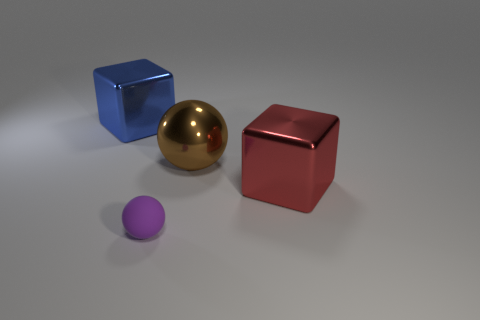Add 3 small gray blocks. How many objects exist? 7 Add 1 red metal things. How many red metal things are left? 2 Add 2 yellow metallic blocks. How many yellow metallic blocks exist? 2 Subtract 0 yellow blocks. How many objects are left? 4 Subtract all cyan spheres. Subtract all blue cylinders. How many spheres are left? 2 Subtract all large spheres. Subtract all big brown things. How many objects are left? 2 